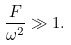<formula> <loc_0><loc_0><loc_500><loc_500>\frac { F } { \omega ^ { 2 } } \gg 1 .</formula> 